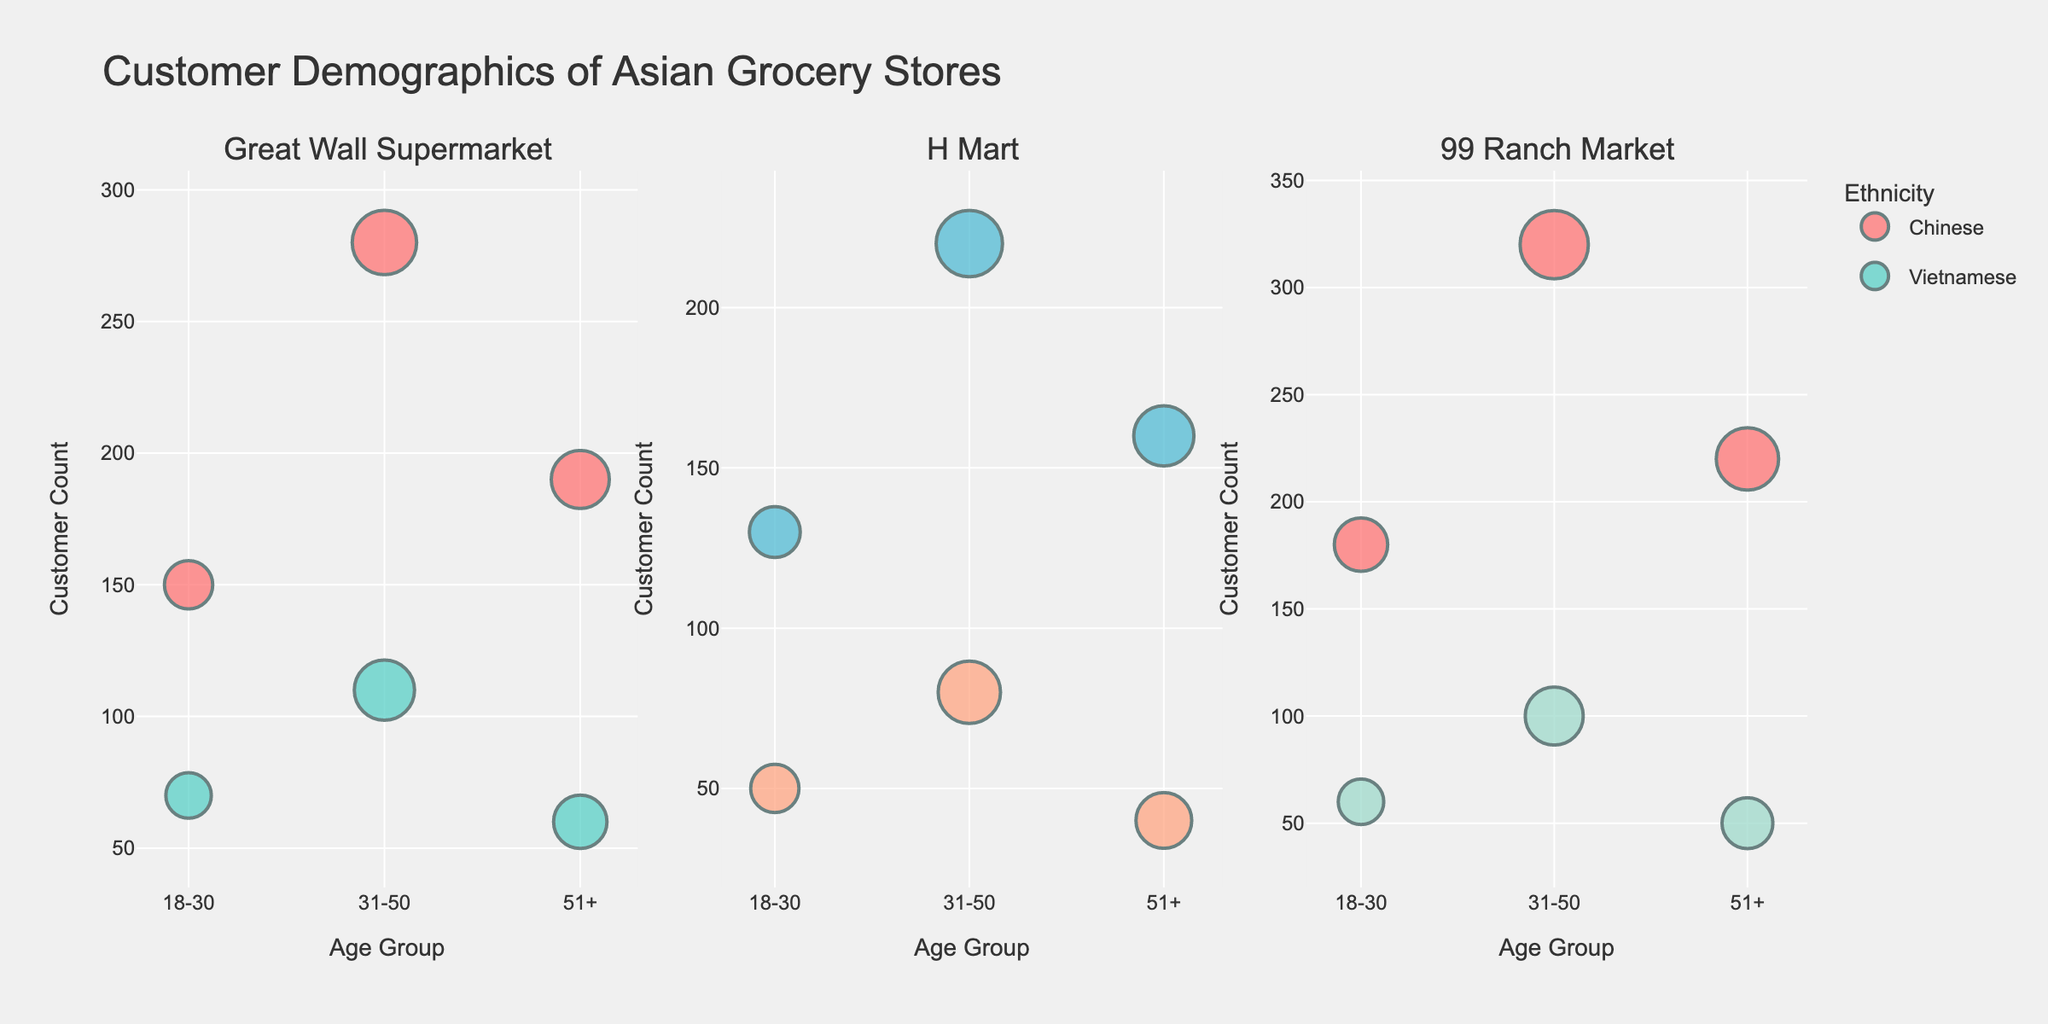What is the title of the figure? The title of the figure is located at the top center of the chart and usually describes the content of the figure.
Answer: Charitable Donations by Cause (2013-2022) How many subplots are there in the figure? The figure consists of multiple sections; counting these sections tells us the number of subplots.
Answer: 5 What was the donation amount to Healthcare in the year 2020? Locate the line representing Healthcare and move to the point corresponding to the year 2020. The y-axis value at that point is the donation amount.
Answer: $100,000 Which cause received the highest donation in 2022? Look at the endpoints for the year 2022 across all lines and identify which has the highest y-axis value.
Answer: Education By how much did the donation to Arts & Culture increase from 2013 to 2022? Find the y-axis values for Arts & Culture for the years 2013 and 2022, then subtract the 2013 value from the 2022 value.
Answer: $50,000 Calculate the average donation to Environmental causes over the decade. Sum the yearly donations for Environmental causes from 2013 to 2022 and divide by 10.
Answer: $45,000 How did the trend in donations to Education compare to that in Poverty Relief from 2016 to 2022? Compare the slopes of the lines representing Education and Poverty Relief between 2016 and 2022, noting whether each is increasing or decreasing.
Answer: Education increased more steeply Which year saw the largest increase in donations to Healthcare? Identify the year-to-year differences in donations to Healthcare and find which difference is the largest.
Answer: 2020 Which cause had the least variation in donation amounts over the ten years? Look at the lines for each cause and see which is the flattest, indicating the least variation.
Answer: Arts & Culture In which year did donations to Environmental causes first reach $50,000? Check the line for Environmental causes to see the first year it crosses the $50,000 mark on the y-axis.
Answer: 2019 